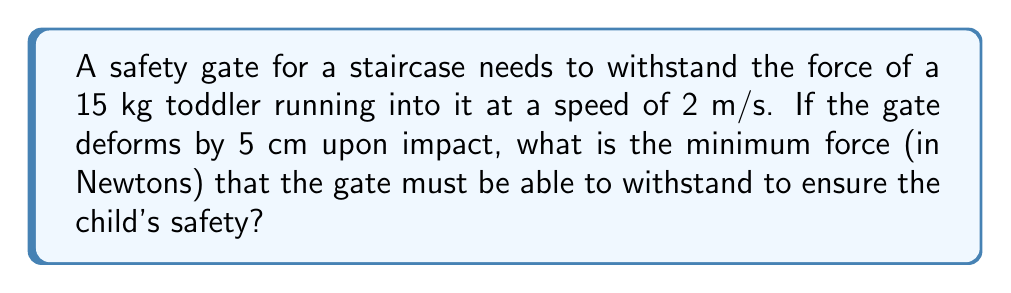Can you solve this math problem? To solve this problem, we'll use the work-energy principle and assume that the gate acts like a spring, converting the child's kinetic energy into elastic potential energy.

Step 1: Calculate the child's kinetic energy
$$ KE = \frac{1}{2}mv^2 $$
Where $m$ is the mass of the child and $v$ is the velocity.
$$ KE = \frac{1}{2} \cdot 15 \text{ kg} \cdot (2 \text{ m/s})^2 = 30 \text{ J} $$

Step 2: Use the work-energy principle
The work done by the gate (W) equals the change in kinetic energy of the child:
$$ W = \Delta KE = 30 \text{ J} $$

Step 3: Calculate the average force using work and displacement
$$ W = F \cdot d $$
Where $F$ is the average force and $d$ is the displacement (deformation of the gate).
$$ 30 \text{ J} = F \cdot 0.05 \text{ m} $$

Step 4: Solve for the force
$$ F = \frac{30 \text{ J}}{0.05 \text{ m}} = 600 \text{ N} $$

Therefore, the safety gate must be able to withstand a minimum force of 600 N to ensure the child's safety.
Answer: 600 N 